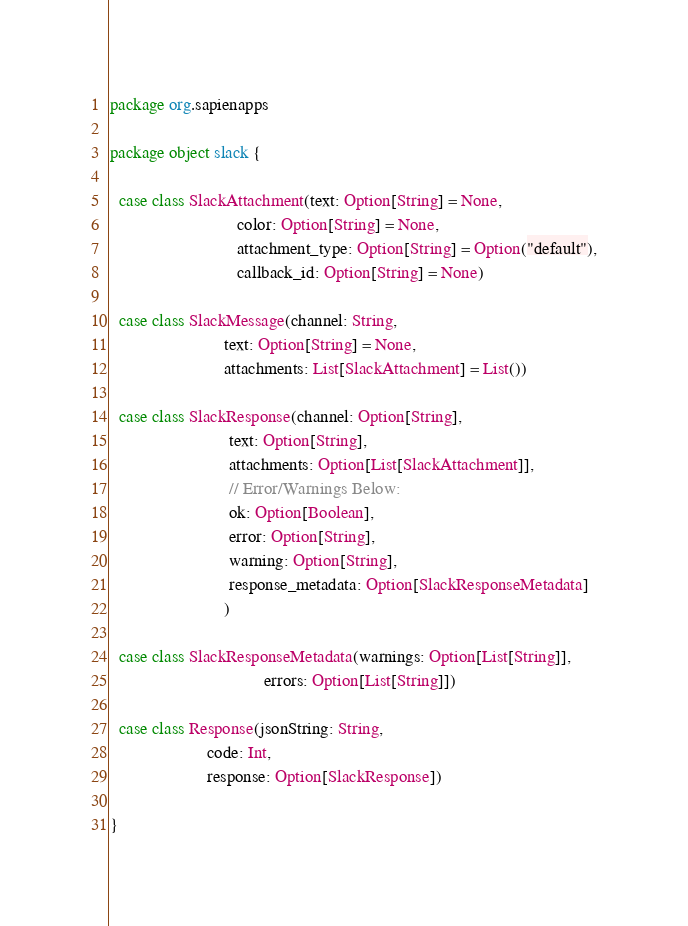Convert code to text. <code><loc_0><loc_0><loc_500><loc_500><_Scala_>package org.sapienapps

package object slack {

  case class SlackAttachment(text: Option[String] = None,
                             color: Option[String] = None,
                             attachment_type: Option[String] = Option("default"),
                             callback_id: Option[String] = None)

  case class SlackMessage(channel: String,
                          text: Option[String] = None,
                          attachments: List[SlackAttachment] = List())

  case class SlackResponse(channel: Option[String],
                           text: Option[String],
                           attachments: Option[List[SlackAttachment]],
                           // Error/Warnings Below:
                           ok: Option[Boolean],
                           error: Option[String],
                           warning: Option[String],
                           response_metadata: Option[SlackResponseMetadata]
                          )

  case class SlackResponseMetadata(warnings: Option[List[String]],
                                   errors: Option[List[String]])

  case class Response(jsonString: String,
                      code: Int,
                      response: Option[SlackResponse])

}
</code> 